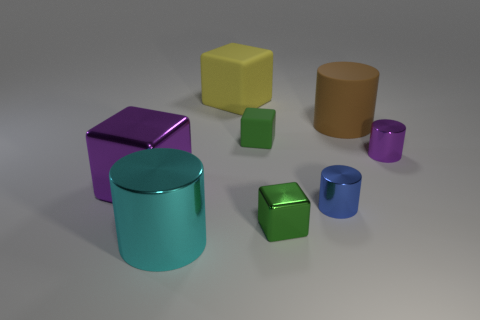What mood does the arrangement and color scheme of the objects convey? The arrangement and pastel color scheme of the objects convey a calm and orderly mood. The soft hues and balanced placement provide a visually harmonious scene. 